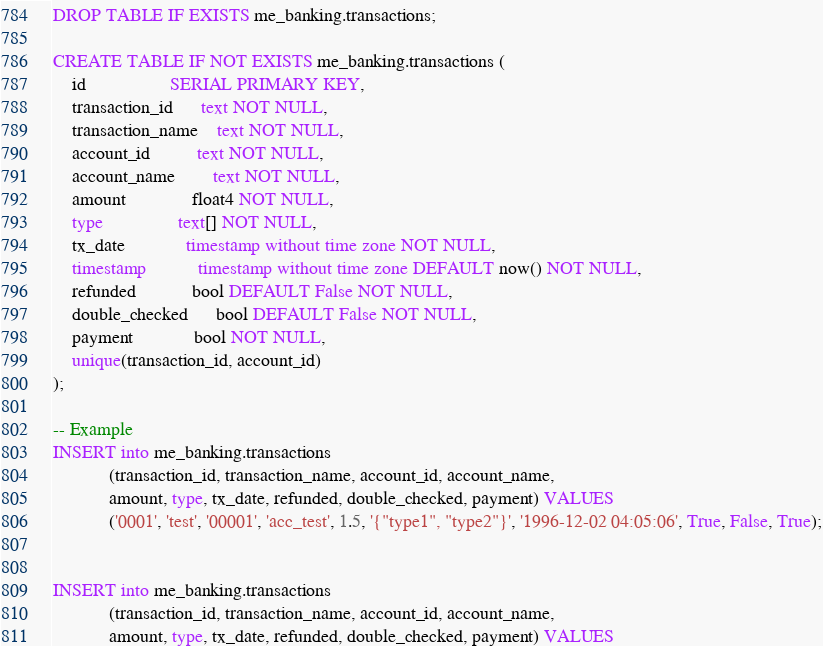Convert code to text. <code><loc_0><loc_0><loc_500><loc_500><_SQL_>
DROP TABLE IF EXISTS me_banking.transactions;

CREATE TABLE IF NOT EXISTS me_banking.transactions (
    id                  SERIAL PRIMARY KEY,
    transaction_id      text NOT NULL,
    transaction_name    text NOT NULL,
    account_id          text NOT NULL,
    account_name        text NOT NULL,
    amount              float4 NOT NULL,
    type                text[] NOT NULL,
    tx_date             timestamp without time zone NOT NULL,
    timestamp           timestamp without time zone DEFAULT now() NOT NULL,
    refunded            bool DEFAULT False NOT NULL,
    double_checked      bool DEFAULT False NOT NULL,
    payment             bool NOT NULL,
    unique(transaction_id, account_id)
);

-- Example
INSERT into me_banking.transactions
            (transaction_id, transaction_name, account_id, account_name,
            amount, type, tx_date, refunded, double_checked, payment) VALUES
            ('0001', 'test', '00001', 'acc_test', 1.5, '{"type1", "type2"}', '1996-12-02 04:05:06', True, False, True);


INSERT into me_banking.transactions
            (transaction_id, transaction_name, account_id, account_name,
            amount, type, tx_date, refunded, double_checked, payment) VALUES</code> 